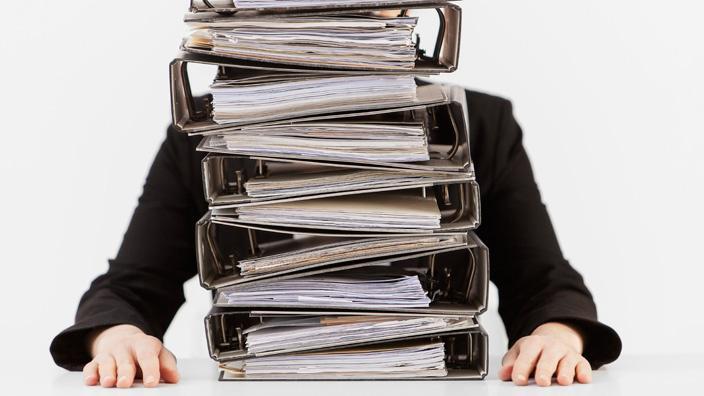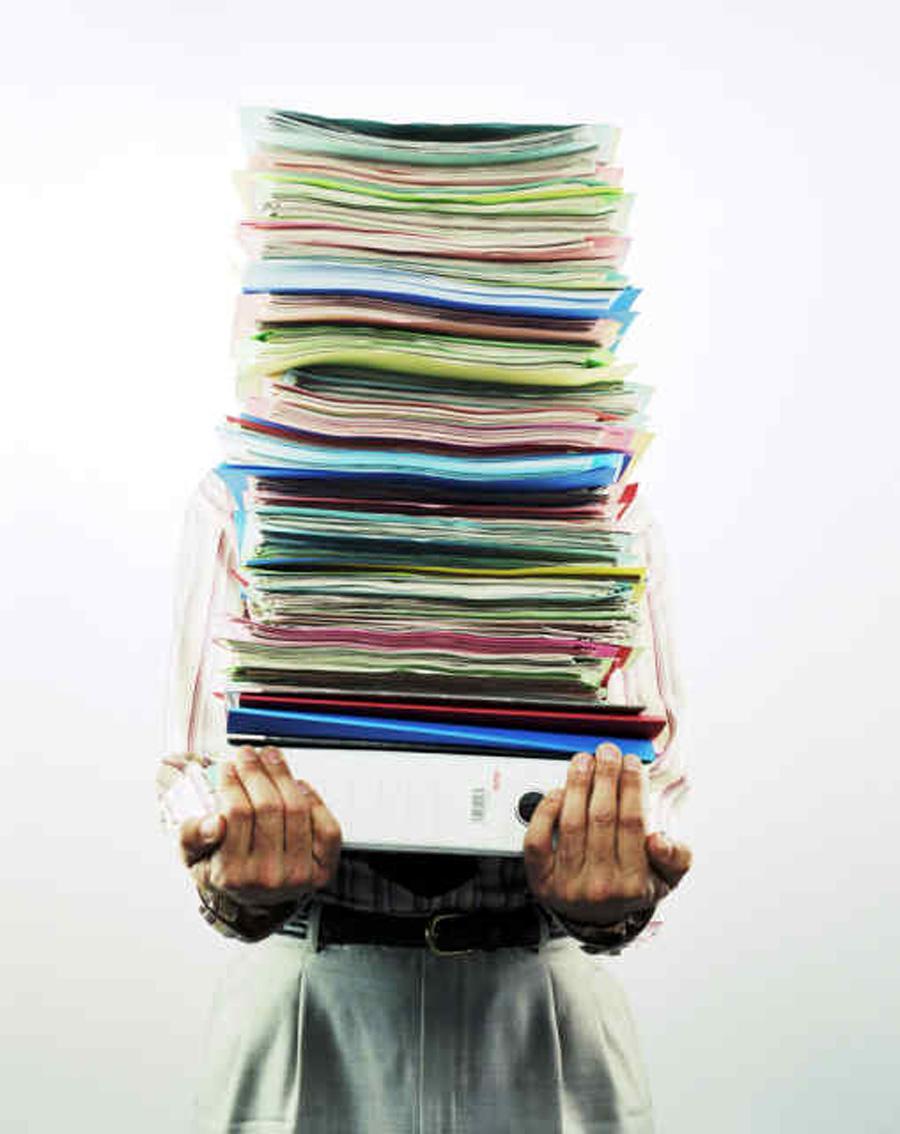The first image is the image on the left, the second image is the image on the right. Assess this claim about the two images: "A man's face is visible near a stack of books.". Correct or not? Answer yes or no. No. The first image is the image on the left, the second image is the image on the right. Evaluate the accuracy of this statement regarding the images: "An image shows only arms in black sleeves sticking out from behind a stack of binders, all with open ends showing.". Is it true? Answer yes or no. Yes. 